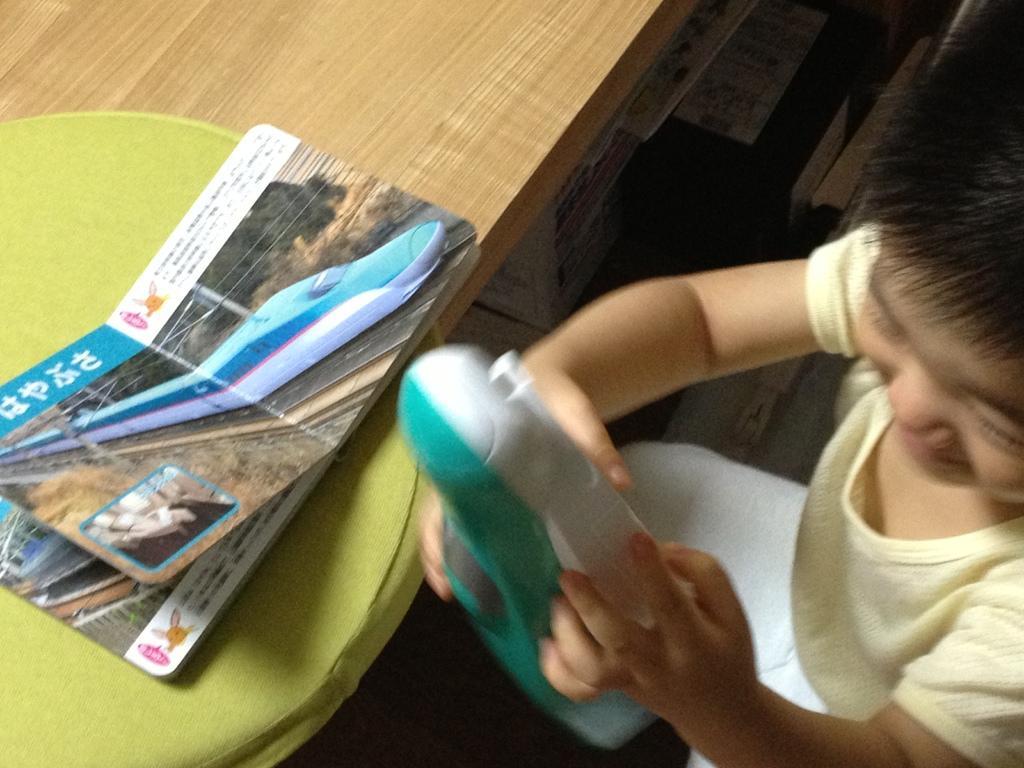Describe this image in one or two sentences. In this picture I can see a kid holding an object, there is a book on the cushion, which is on the table and there are some objects. 